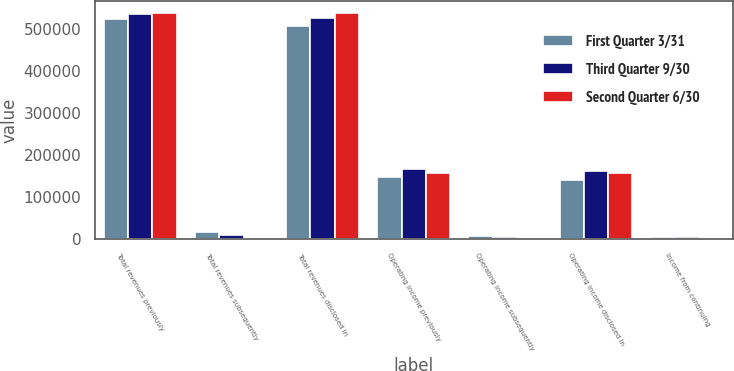<chart> <loc_0><loc_0><loc_500><loc_500><stacked_bar_chart><ecel><fcel>Total revenues previously<fcel>Total revenues subsequently<fcel>Total revenues disclosed in<fcel>Operating income previously<fcel>Operating income subsequently<fcel>Operating income disclosed in<fcel>Income from continuing<nl><fcel>First Quarter 3/31<fcel>522812<fcel>15407<fcel>507405<fcel>146847<fcel>5890<fcel>140957<fcel>5382<nl><fcel>Third Quarter 9/30<fcel>535525<fcel>9924<fcel>525601<fcel>165859<fcel>3585<fcel>162274<fcel>3363<nl><fcel>Second Quarter 6/30<fcel>538319<fcel>1466<fcel>536853<fcel>156570<fcel>745<fcel>155825<fcel>663<nl></chart> 